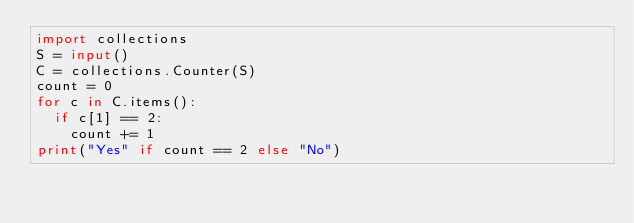Convert code to text. <code><loc_0><loc_0><loc_500><loc_500><_Python_>import collections
S = input()
C = collections.Counter(S)
count = 0
for c in C.items():
  if c[1] == 2:
    count += 1
print("Yes" if count == 2 else "No")    
  </code> 